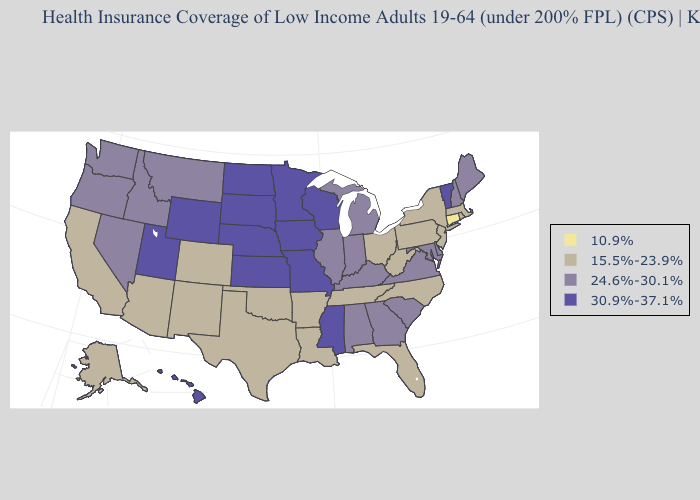Name the states that have a value in the range 15.5%-23.9%?
Concise answer only. Alaska, Arizona, Arkansas, California, Colorado, Florida, Louisiana, Massachusetts, New Jersey, New Mexico, New York, North Carolina, Ohio, Oklahoma, Pennsylvania, Rhode Island, Tennessee, Texas, West Virginia. Among the states that border Arkansas , does Tennessee have the highest value?
Be succinct. No. Does New Jersey have the lowest value in the Northeast?
Write a very short answer. No. What is the value of Alaska?
Short answer required. 15.5%-23.9%. What is the lowest value in the Northeast?
Write a very short answer. 10.9%. Does the map have missing data?
Answer briefly. No. Does Missouri have the highest value in the MidWest?
Write a very short answer. Yes. Name the states that have a value in the range 30.9%-37.1%?
Answer briefly. Hawaii, Iowa, Kansas, Minnesota, Mississippi, Missouri, Nebraska, North Dakota, South Dakota, Utah, Vermont, Wisconsin, Wyoming. What is the lowest value in states that border Connecticut?
Keep it brief. 15.5%-23.9%. Name the states that have a value in the range 24.6%-30.1%?
Quick response, please. Alabama, Delaware, Georgia, Idaho, Illinois, Indiana, Kentucky, Maine, Maryland, Michigan, Montana, Nevada, New Hampshire, Oregon, South Carolina, Virginia, Washington. Name the states that have a value in the range 15.5%-23.9%?
Be succinct. Alaska, Arizona, Arkansas, California, Colorado, Florida, Louisiana, Massachusetts, New Jersey, New Mexico, New York, North Carolina, Ohio, Oklahoma, Pennsylvania, Rhode Island, Tennessee, Texas, West Virginia. Which states have the lowest value in the South?
Quick response, please. Arkansas, Florida, Louisiana, North Carolina, Oklahoma, Tennessee, Texas, West Virginia. Name the states that have a value in the range 24.6%-30.1%?
Answer briefly. Alabama, Delaware, Georgia, Idaho, Illinois, Indiana, Kentucky, Maine, Maryland, Michigan, Montana, Nevada, New Hampshire, Oregon, South Carolina, Virginia, Washington. Does Tennessee have a higher value than Connecticut?
Keep it brief. Yes. What is the highest value in the West ?
Short answer required. 30.9%-37.1%. 